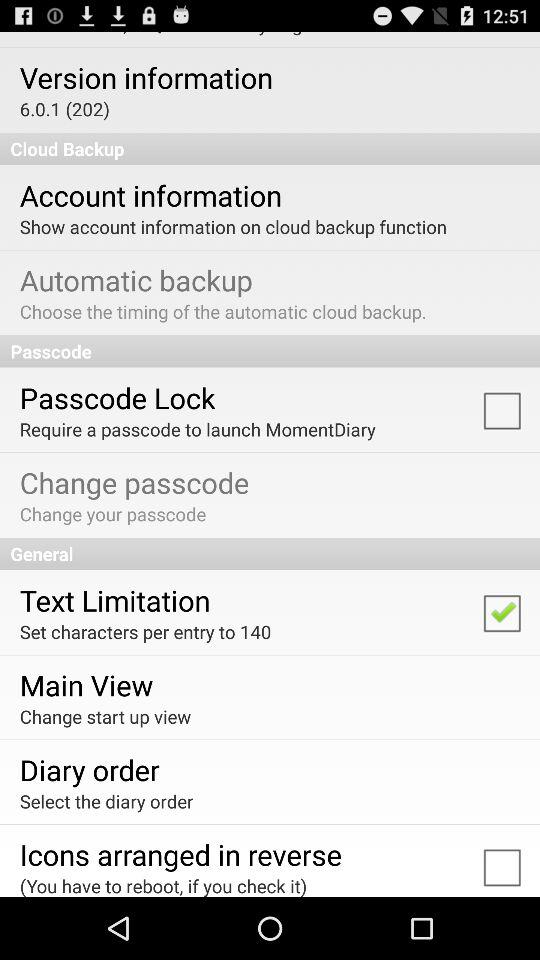Which option is selected for set characters? The option that is selected for set characters is "Text Limitation". 